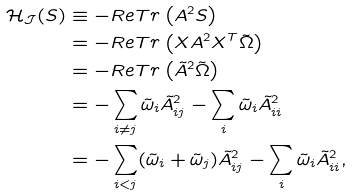Convert formula to latex. <formula><loc_0><loc_0><loc_500><loc_500>\mathcal { H } _ { \mathcal { J } } ( S ) & \equiv - R e T r \left ( A ^ { 2 } S \right ) \\ & = - R e T r \left ( X A ^ { 2 } X ^ { T } \tilde { \Omega } \right ) \\ & = - R e T r \left ( \tilde { A } ^ { 2 } \tilde { \Omega } \right ) \\ & = - \sum _ { i \neq j } \tilde { \omega } _ { i } \tilde { A } _ { i j } ^ { 2 } - \sum _ { i } \tilde { \omega } _ { i } \tilde { A } _ { i i } ^ { 2 } \\ & = - \sum _ { i < j } ( \tilde { \omega } _ { i } + \tilde { \omega } _ { j } ) \tilde { A } _ { i j } ^ { 2 } - \sum _ { i } \tilde { \omega } _ { i } \tilde { A } _ { i i } ^ { 2 } ,</formula> 